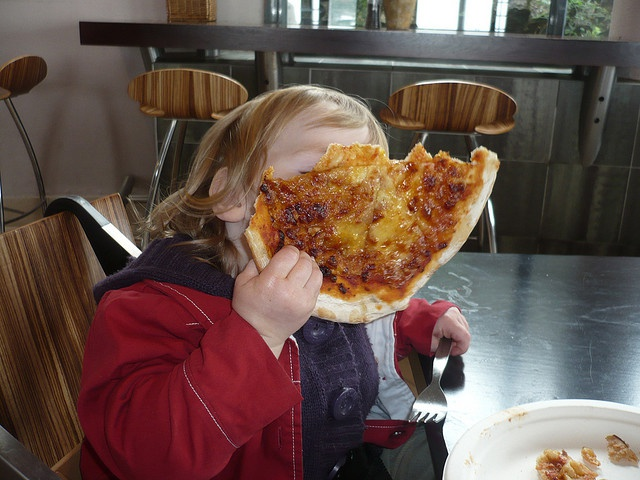Describe the objects in this image and their specific colors. I can see people in gray, maroon, black, and brown tones, dining table in gray, lightgray, and darkgray tones, pizza in gray, brown, maroon, and tan tones, dining table in gray, black, and white tones, and chair in gray, black, and maroon tones in this image. 